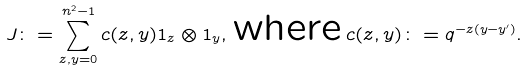Convert formula to latex. <formula><loc_0><loc_0><loc_500><loc_500>J \colon = \sum _ { z , y = 0 } ^ { n ^ { 2 } - 1 } c ( z , y ) 1 _ { z } \otimes 1 _ { y } , \, \text {where} \, c ( z , y ) \colon = q ^ { - z ( y - y ^ { \prime } ) } .</formula> 